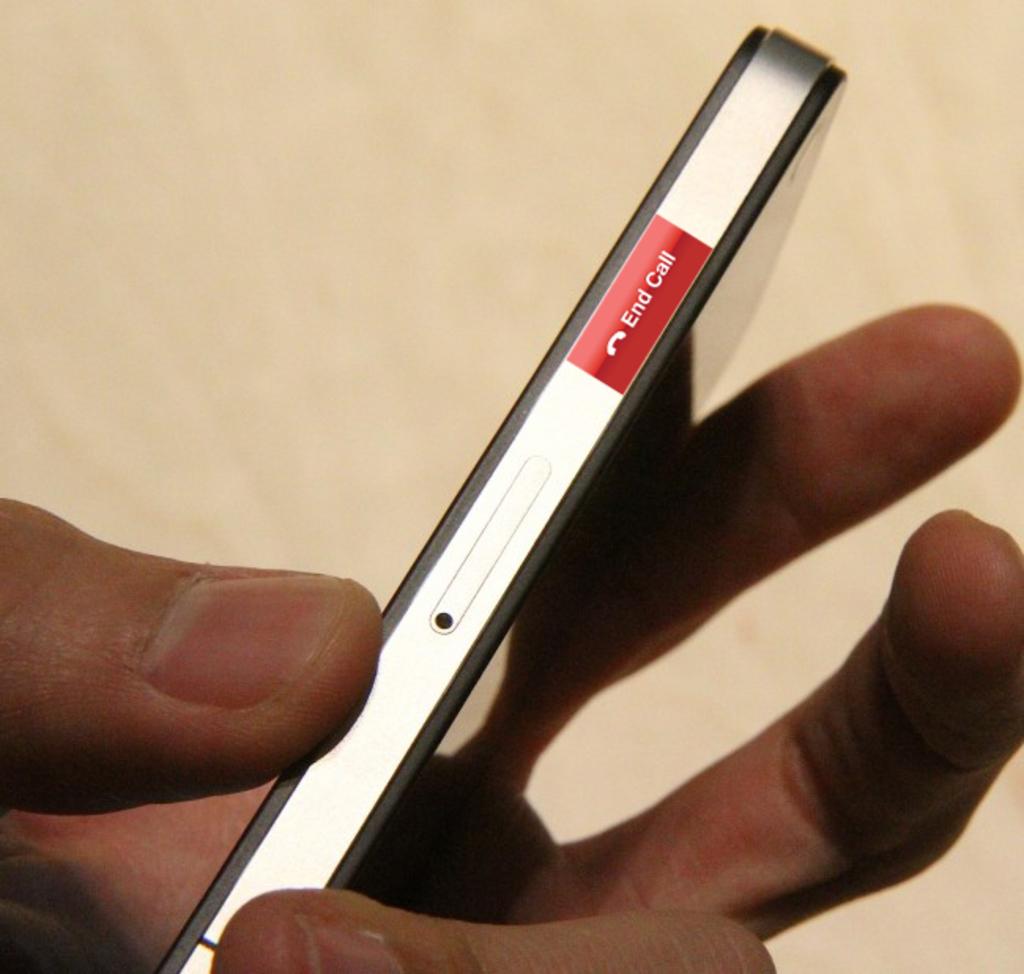What option is available on the side of the phone?
Your answer should be compact. End call. What happens if you press the red button?
Give a very brief answer. End call. 